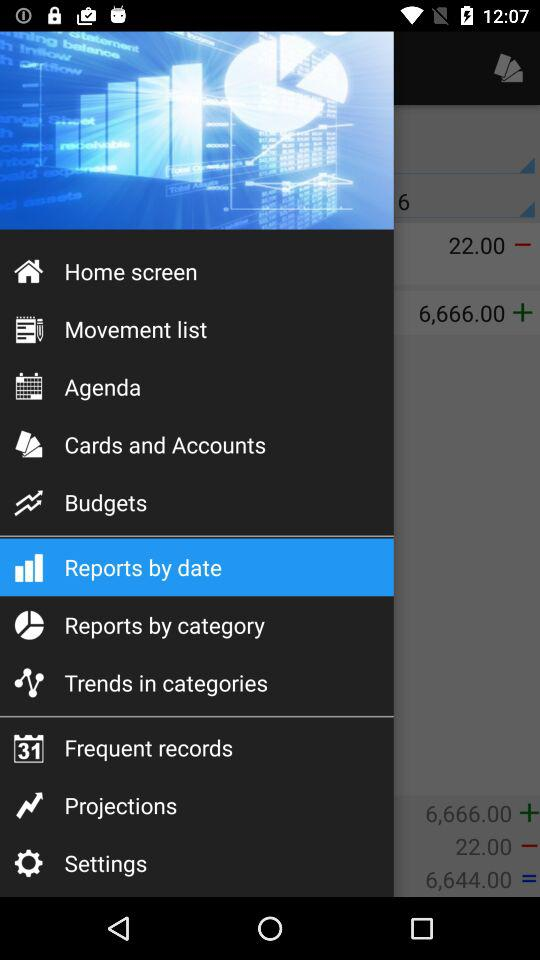How many notifications are there in "Settings"?
When the provided information is insufficient, respond with <no answer>. <no answer> 